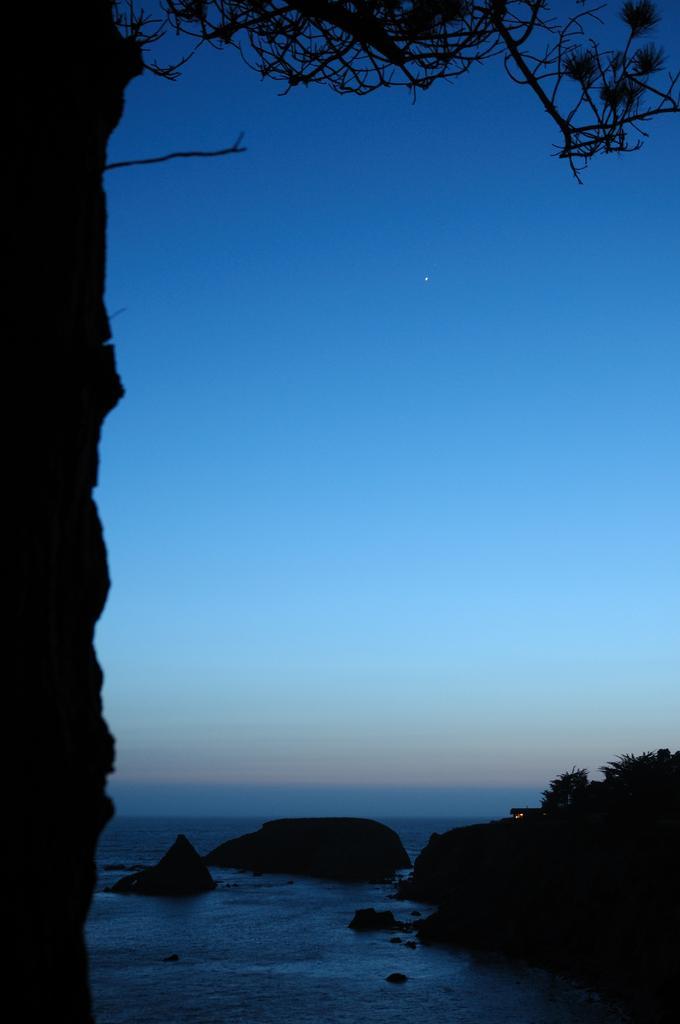Can you describe this image briefly? In this image we can see a tree, plants, rocks and we can also see the sky. 